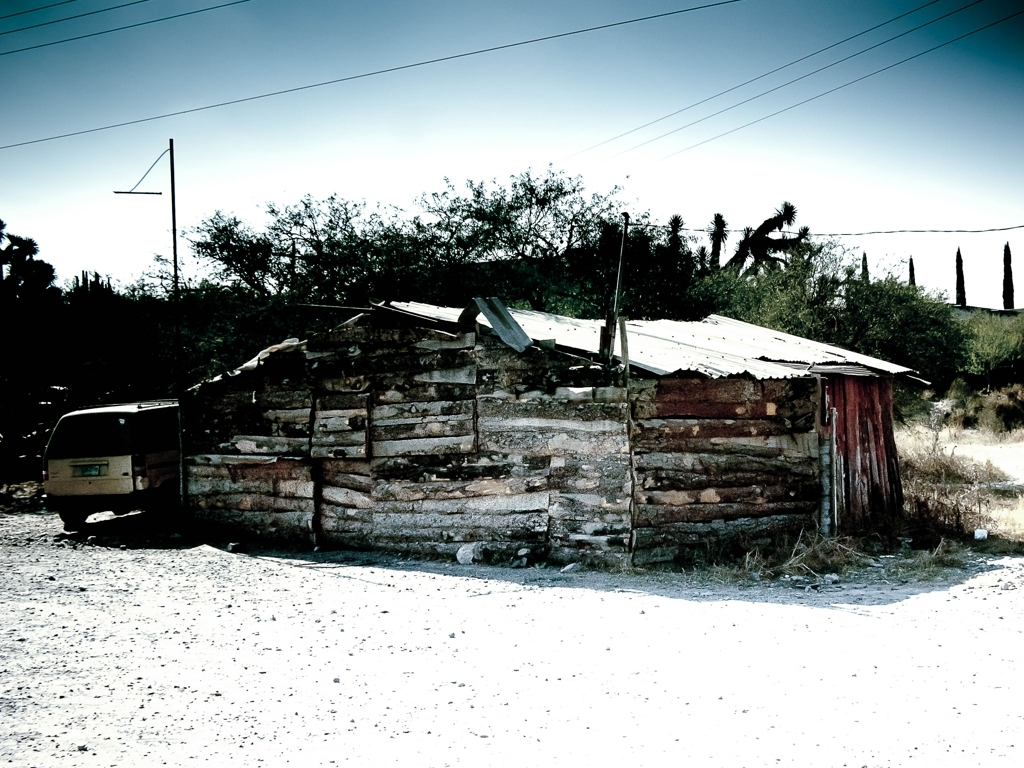What can you tell me about the condition and likely use of the structure? The structure appears weathered and partially deteriorated, indicating that it may be old and currently disused. The corrugated metal roof and rustic stone walls could suggest that it previously served a utility purpose, perhaps as a storage shed or a similar functional space. 